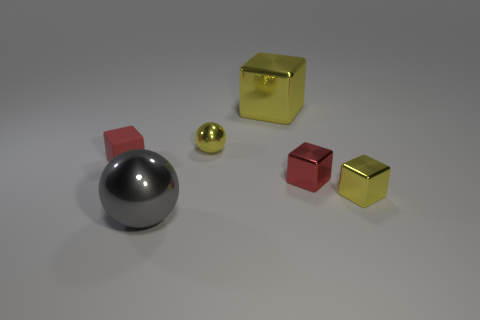Is the small matte block the same color as the small shiny sphere?
Your response must be concise. No. How many red metal blocks are there?
Offer a terse response. 1. How many balls are large gray metal things or metal objects?
Your answer should be compact. 2. There is a small red cube that is left of the gray metallic ball; what number of rubber things are in front of it?
Keep it short and to the point. 0. Is the material of the small yellow block the same as the tiny ball?
Your response must be concise. Yes. The metallic block that is the same color as the tiny matte thing is what size?
Your response must be concise. Small. Are there any big spheres made of the same material as the small ball?
Your answer should be very brief. Yes. There is a ball that is in front of the yellow shiny thing right of the red block that is to the right of the big shiny cube; what color is it?
Your response must be concise. Gray. How many red objects are either blocks or small things?
Offer a terse response. 2. How many other small metallic objects have the same shape as the gray shiny thing?
Ensure brevity in your answer.  1. 